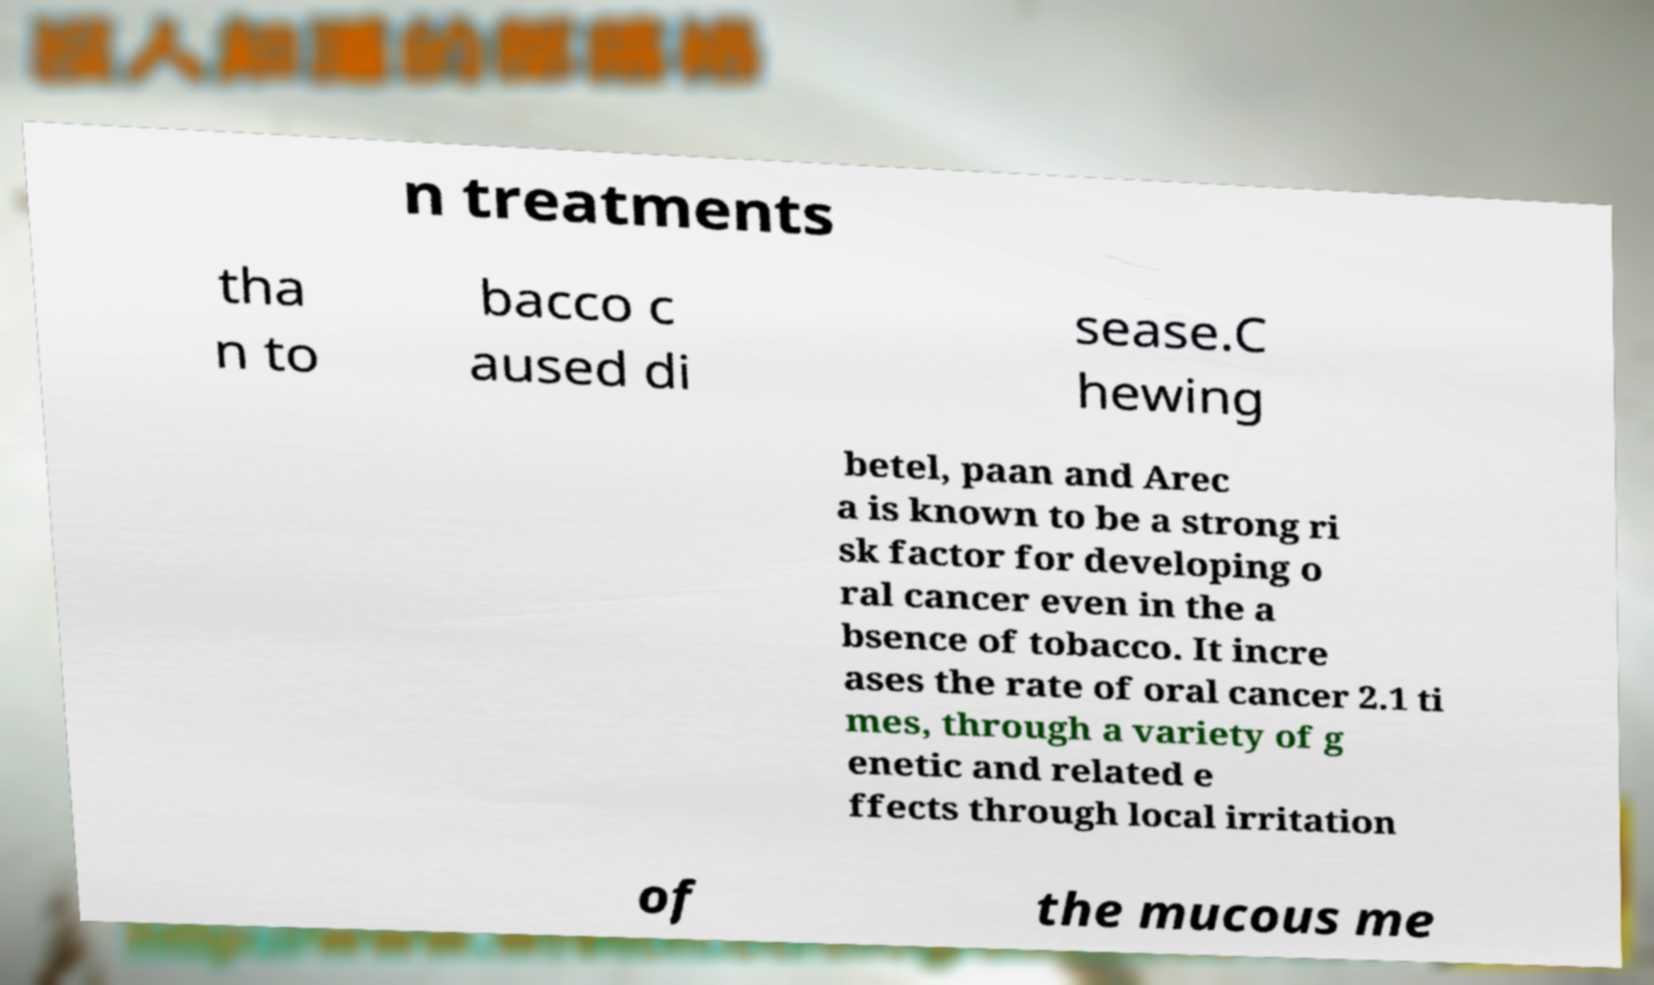There's text embedded in this image that I need extracted. Can you transcribe it verbatim? n treatments tha n to bacco c aused di sease.C hewing betel, paan and Arec a is known to be a strong ri sk factor for developing o ral cancer even in the a bsence of tobacco. It incre ases the rate of oral cancer 2.1 ti mes, through a variety of g enetic and related e ffects through local irritation of the mucous me 